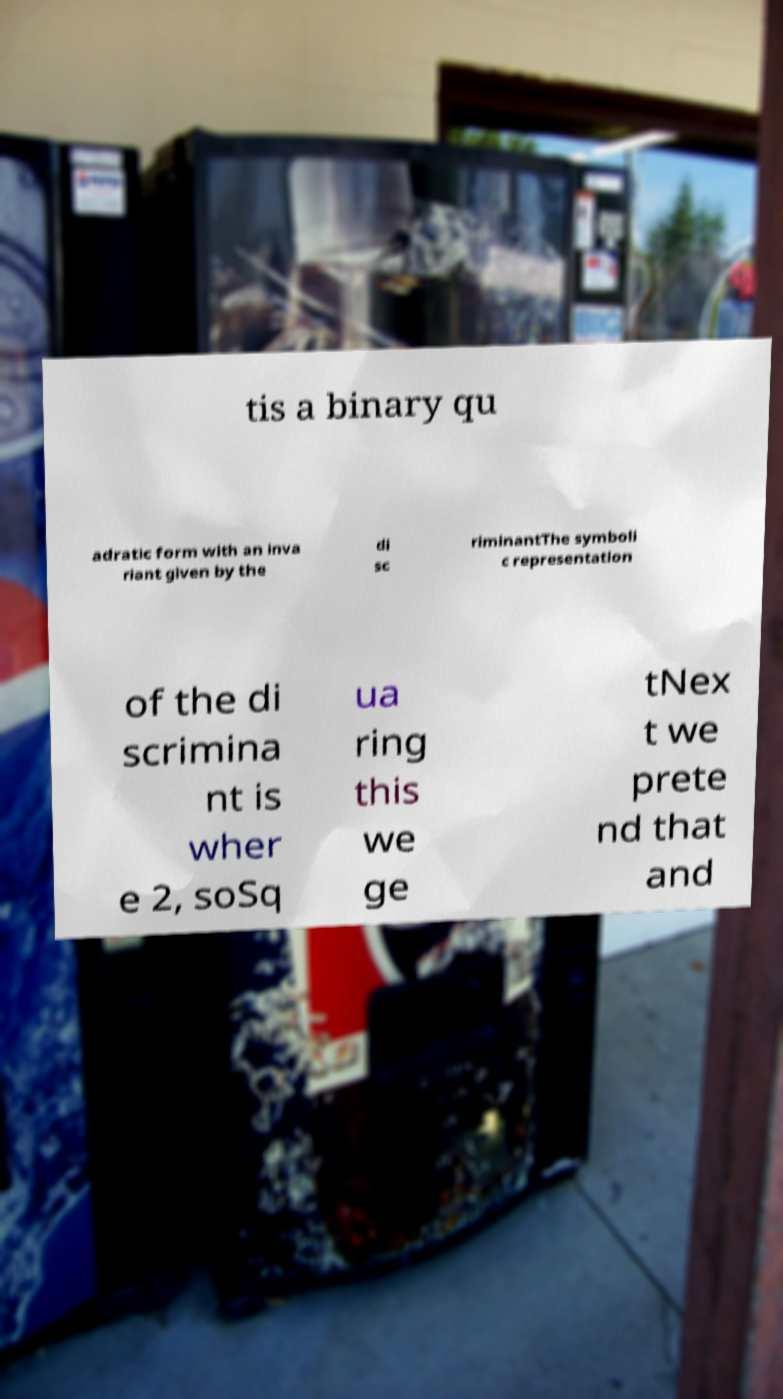Could you assist in decoding the text presented in this image and type it out clearly? tis a binary qu adratic form with an inva riant given by the di sc riminantThe symboli c representation of the di scrimina nt is wher e 2, soSq ua ring this we ge tNex t we prete nd that and 